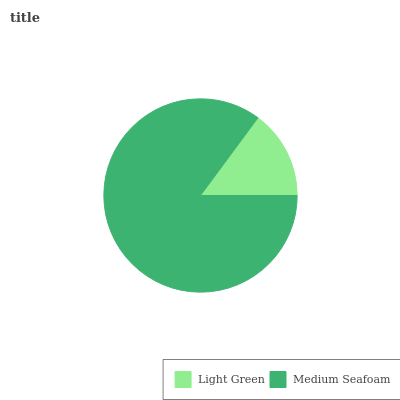Is Light Green the minimum?
Answer yes or no. Yes. Is Medium Seafoam the maximum?
Answer yes or no. Yes. Is Medium Seafoam the minimum?
Answer yes or no. No. Is Medium Seafoam greater than Light Green?
Answer yes or no. Yes. Is Light Green less than Medium Seafoam?
Answer yes or no. Yes. Is Light Green greater than Medium Seafoam?
Answer yes or no. No. Is Medium Seafoam less than Light Green?
Answer yes or no. No. Is Medium Seafoam the high median?
Answer yes or no. Yes. Is Light Green the low median?
Answer yes or no. Yes. Is Light Green the high median?
Answer yes or no. No. Is Medium Seafoam the low median?
Answer yes or no. No. 